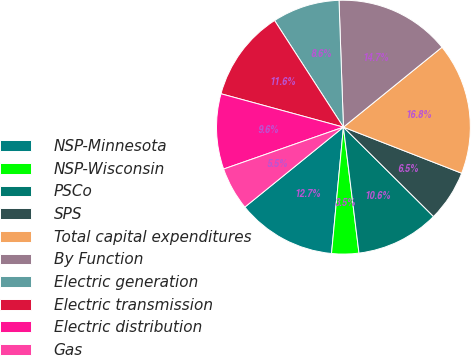Convert chart to OTSL. <chart><loc_0><loc_0><loc_500><loc_500><pie_chart><fcel>NSP-Minnesota<fcel>NSP-Wisconsin<fcel>PSCo<fcel>SPS<fcel>Total capital expenditures<fcel>By Function<fcel>Electric generation<fcel>Electric transmission<fcel>Electric distribution<fcel>Gas<nl><fcel>12.66%<fcel>3.45%<fcel>10.61%<fcel>6.52%<fcel>16.76%<fcel>14.71%<fcel>8.57%<fcel>11.64%<fcel>9.59%<fcel>5.49%<nl></chart> 